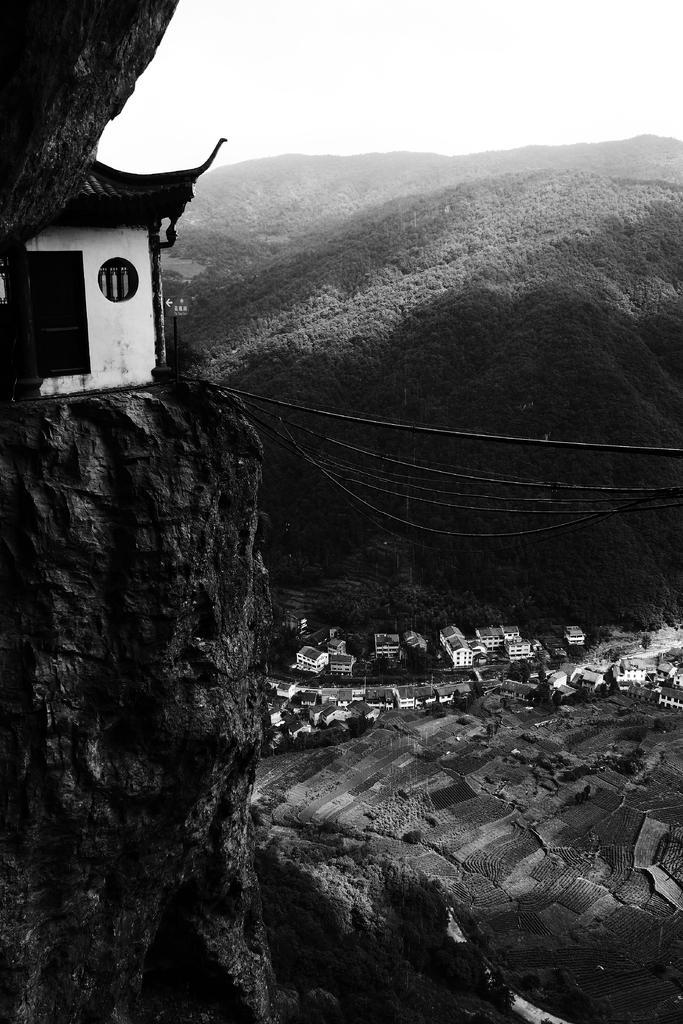How would you summarize this image in a sentence or two? This is a black and white picture. On the left side, we see the rocks and a building in white color. We see the wires. At the bottom, we see the trees. In the middle, we see the buildings. There are trees and the hills in the background. At the top, we see the sky. 